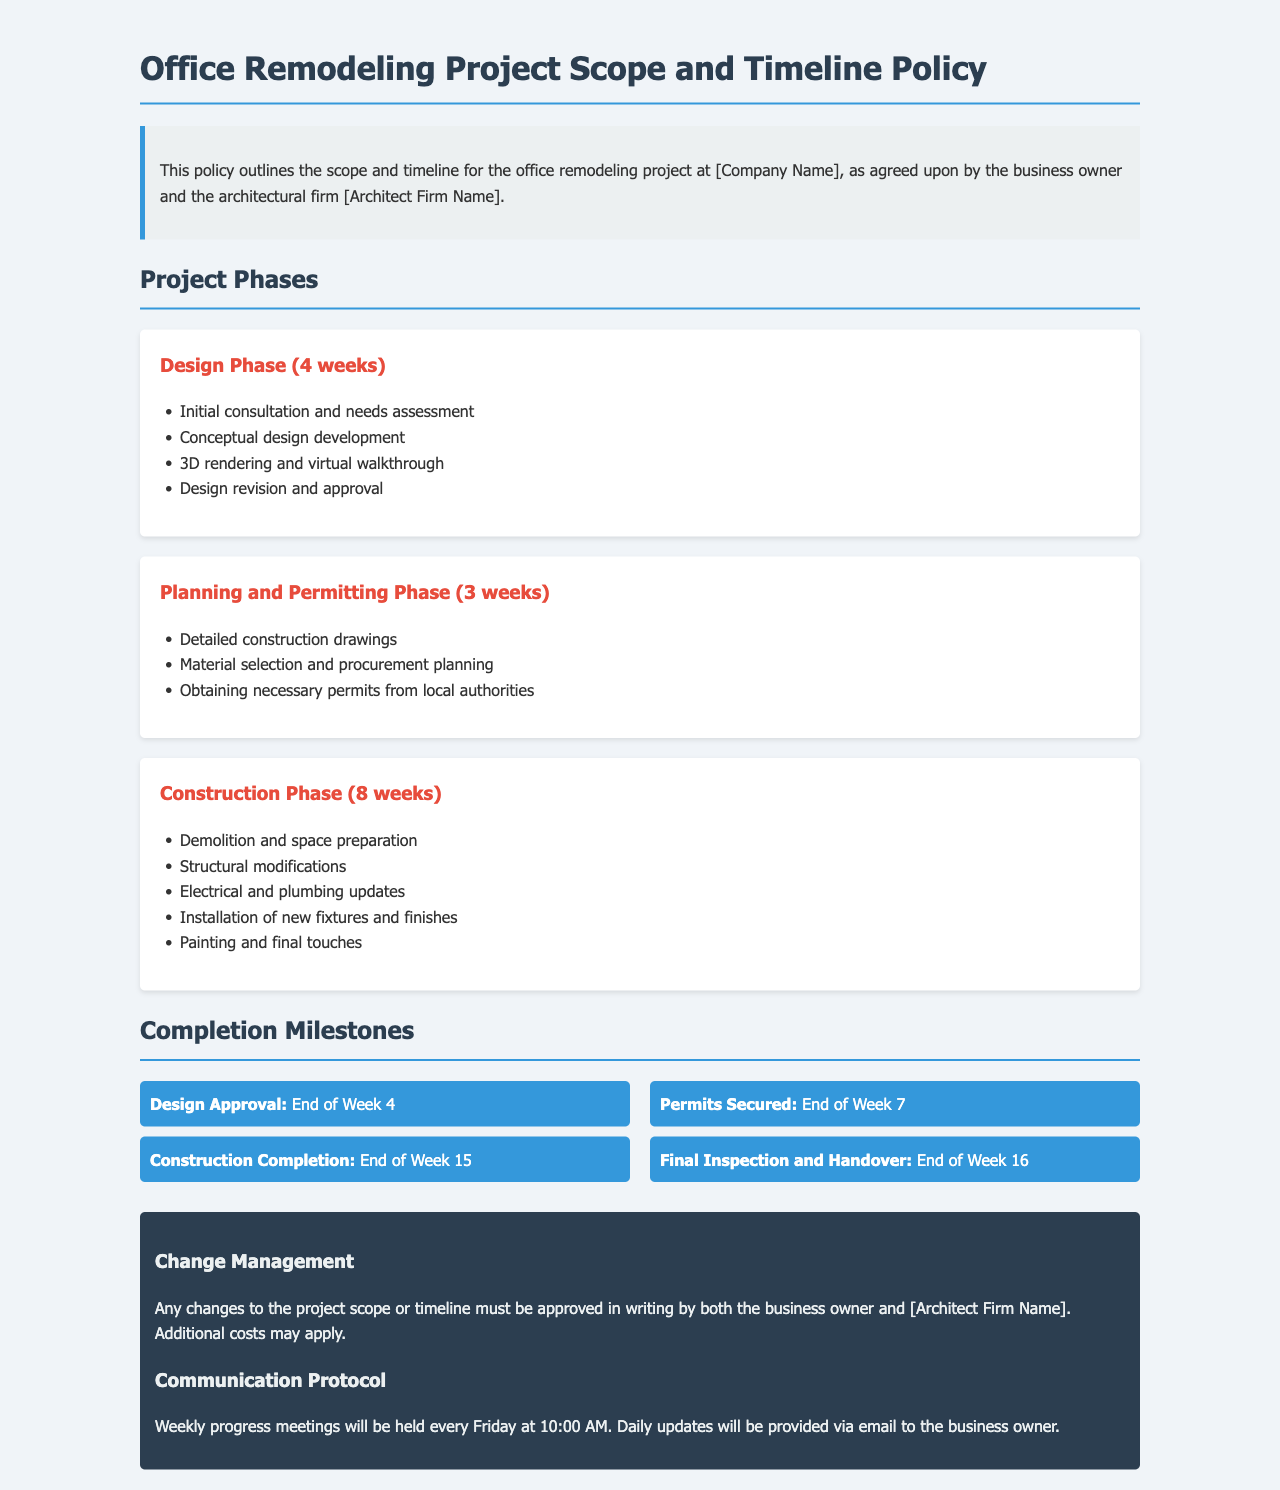What is the duration of the Design Phase? The Design Phase lasts for a total of 4 weeks, as indicated in the project phases section.
Answer: 4 weeks What milestone is set for the end of Week 16? The milestone at the end of Week 16 is related to the final inspection and handover, detailed in the completion milestones section.
Answer: Final Inspection and Handover How many weeks is allocated for the Construction Phase? The Construction Phase is allocated 8 weeks, which can be found under the project phases section.
Answer: 8 weeks What is required before starting the Construction Phase? Before starting the Construction Phase, permits must be secured as outlined in the project timeline.
Answer: Permits Secured What is the communication frequency during the project? The communication frequency during the project is weekly progress meetings, as specified in the change management section of the document.
Answer: Weekly What action is necessary for changes to the project scope? Any changes to the project scope must be approved in writing by both parties, as mentioned in the change management section.
Answer: Approved in writing What is included in the Planning and Permitting Phase? The Planning and Permitting Phase includes detailed construction drawings, material selection, and obtaining permits, as listed in the project phases.
Answer: Detailed construction drawings What day and time will progress meetings be held? Progress meetings will be held every Friday at 10:00 AM, as stated in the communication protocol.
Answer: Friday at 10:00 AM 